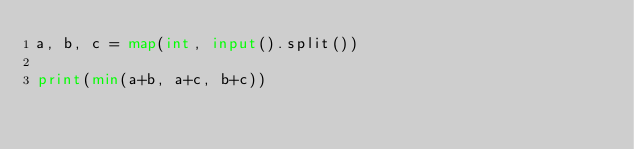Convert code to text. <code><loc_0><loc_0><loc_500><loc_500><_Python_>a, b, c = map(int, input().split())

print(min(a+b, a+c, b+c))</code> 